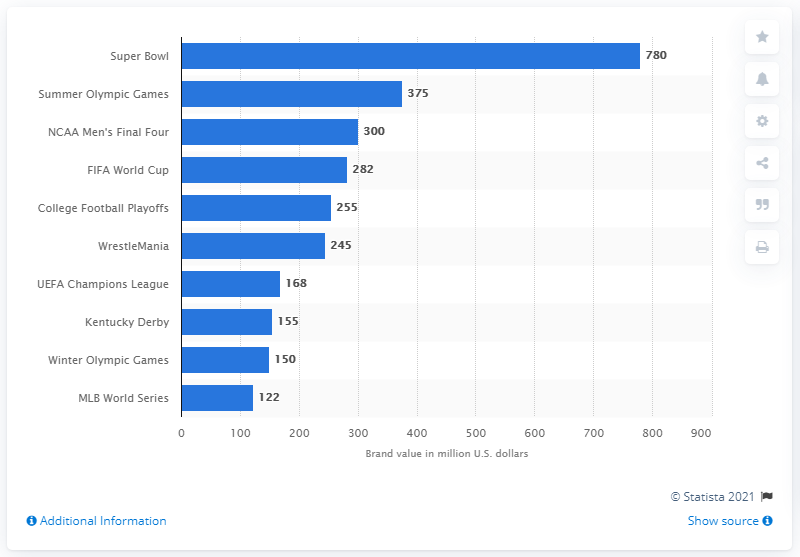Give some essential details in this illustration. The Super Bowl is worth $780 million. The Super Bowl is widely considered to be the most valuable sports event brand in the world. 